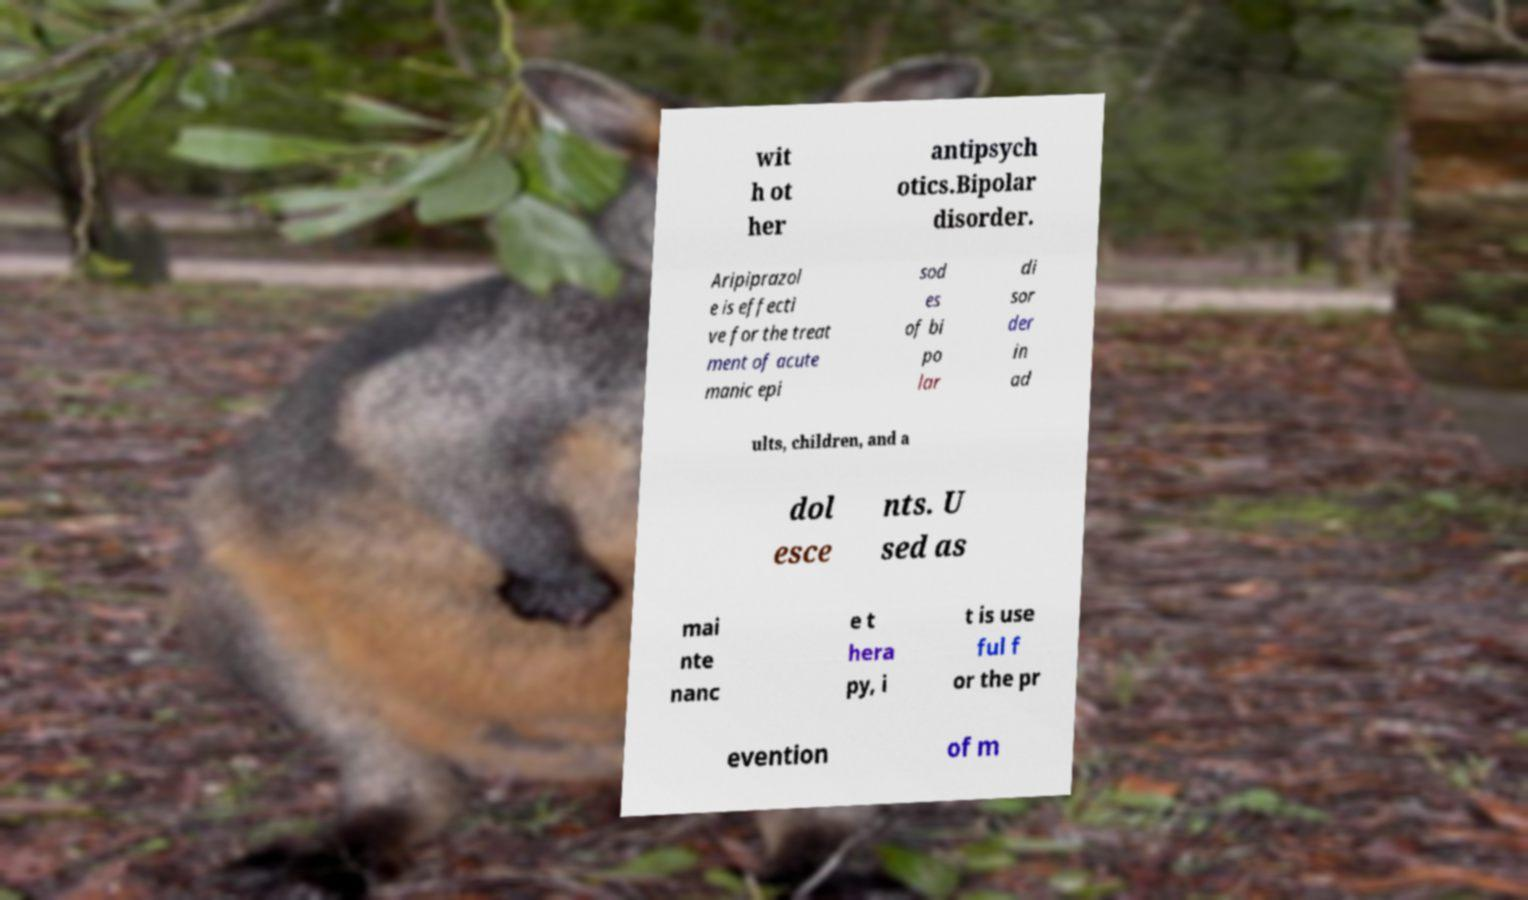There's text embedded in this image that I need extracted. Can you transcribe it verbatim? wit h ot her antipsych otics.Bipolar disorder. Aripiprazol e is effecti ve for the treat ment of acute manic epi sod es of bi po lar di sor der in ad ults, children, and a dol esce nts. U sed as mai nte nanc e t hera py, i t is use ful f or the pr evention of m 